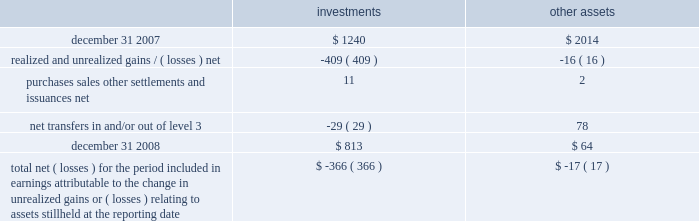A wholly-owned subsidiary of the company is a registered life insurance company that maintains separate account assets , representing segregated funds held for purposes of funding individual and group pension contracts , and equal and offsetting separate account liabilities .
At decem - ber 31 , 2008 and 2007 , the level 3 separate account assets were approximately $ 4 and $ 12 , respectively .
The changes in level 3 assets primarily relate to purchases , sales and gains/ ( losses ) .
The net investment income and net gains and losses attributable to separate account assets accrue directly to the contract owner and are not reported as non-operating income ( expense ) on the consolidated statements of income .
Level 3 assets , which includes equity method investments or consolidated investments of real estate funds , private equity funds and funds of private equity funds are valued based upon valuations received from internal as well as third party fund managers .
Fair valuations at the underlying funds are based on a combination of methods which may include third-party independent appraisals and discounted cash flow techniques .
Direct investments in private equity companies held by funds of private equity funds are valued based on an assessment of each under - lying investment , incorporating evaluation of additional significant third party financing , changes in valuations of comparable peer companies and the business environment of the companies , among other factors .
See note 2 for further detail on the fair value policies by the underlying funds .
Changes in level 3 assets measured at fair value on a recurring basis for the year ended december 31 , 2008 .
Total net ( losses ) for the period included in earnings attributable to the change in unrealized gains or ( losses ) relating to assets still held at the reporting date $ ( 366 ) $ ( 17 ) realized and unrealized gains and losses recorded for level 3 assets are reported in non-operating income ( expense ) on the consolidated statements of income .
Non-controlling interest expense is recorded for consoli- dated investments to reflect the portion of gains and losses not attributable to the company .
The company transfers assets in and/or out of level 3 as significant inputs , including performance attributes , used for the fair value measurement become observable .
Variable interest entities in the normal course of business , the company is the manager of various types of sponsored investment vehicles , including collateralized debt obligations and sponsored investment funds , that may be considered vies .
The company receives management fees or other incen- tive related fees for its services and may from time to time own equity or debt securities or enter into derivatives with the vehicles , each of which are considered variable inter- ests .
The company engages in these variable interests principally to address client needs through the launch of such investment vehicles .
The vies are primarily financed via capital contributed by equity and debt holders .
The company 2019s involvement in financing the operations of the vies is limited to its equity interests , unfunded capital commitments for certain sponsored investment funds and its capital support agreements for two enhanced cash funds .
The primary beneficiary of a vie is the party that absorbs a majority of the entity 2019s expected losses , receives a major - ity of the entity 2019s expected residual returns or both as a result of holding variable interests .
In order to determine whether the company is the primary beneficiary of a vie , management must make significant estimates and assumptions of probable future cash flows and assign probabilities to different cash flow scenarios .
Assumptions made in such analyses include , but are not limited to , market prices of securities , market interest rates , poten- tial credit defaults on individual securities or default rates on a portfolio of securities , gain realization , liquidity or marketability of certain securities , discount rates and the probability of certain other outcomes .
Vies in which blackrock is the primary beneficiary at december 31 , 2008 , the company was the primary beneficiary of three vies , which resulted in consolidation of three sponsored investment funds ( including two cash management funds and one private equity fund of funds ) .
Creditors of the vies do not have recourse to the credit of the company .
During 2008 , the company determined it became the primary beneficiary of two enhanced cash management funds as a result of concluding that under various cash 177528_txt_59_96:layout 1 3/26/09 10:32 pm page 73 .
For 2017 , what was the total net losses for the period ? ( $ )? 
Rationale: it does not indicate the scale ( thousands , millions etc )
Computations: (366 + 17)
Answer: 383.0. 